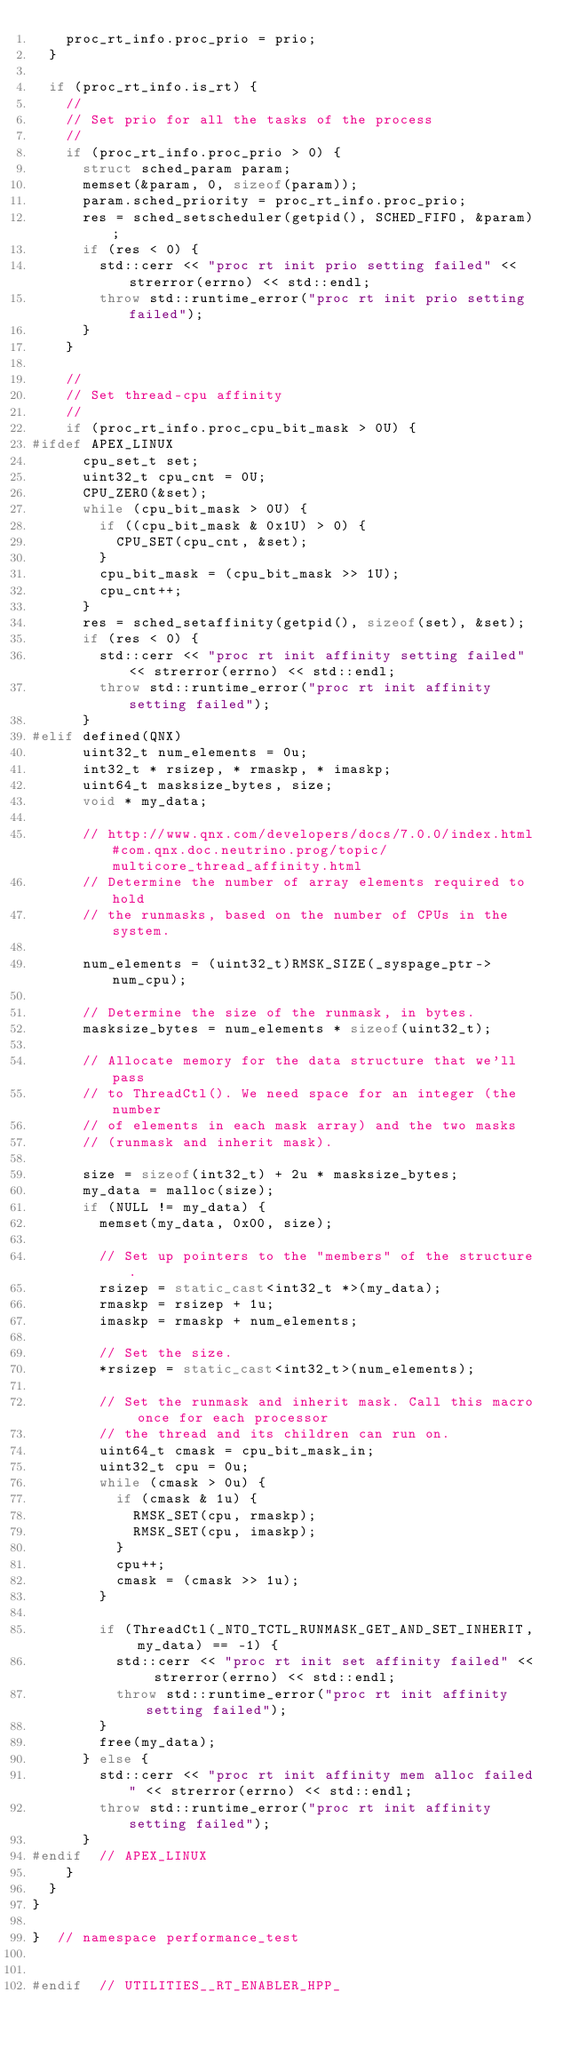Convert code to text. <code><loc_0><loc_0><loc_500><loc_500><_C++_>    proc_rt_info.proc_prio = prio;
  }

  if (proc_rt_info.is_rt) {
    //
    // Set prio for all the tasks of the process
    //
    if (proc_rt_info.proc_prio > 0) {
      struct sched_param param;
      memset(&param, 0, sizeof(param));
      param.sched_priority = proc_rt_info.proc_prio;
      res = sched_setscheduler(getpid(), SCHED_FIFO, &param);
      if (res < 0) {
        std::cerr << "proc rt init prio setting failed" << strerror(errno) << std::endl;
        throw std::runtime_error("proc rt init prio setting failed");
      }
    }

    //
    // Set thread-cpu affinity
    //
    if (proc_rt_info.proc_cpu_bit_mask > 0U) {
#ifdef APEX_LINUX
      cpu_set_t set;
      uint32_t cpu_cnt = 0U;
      CPU_ZERO(&set);
      while (cpu_bit_mask > 0U) {
        if ((cpu_bit_mask & 0x1U) > 0) {
          CPU_SET(cpu_cnt, &set);
        }
        cpu_bit_mask = (cpu_bit_mask >> 1U);
        cpu_cnt++;
      }
      res = sched_setaffinity(getpid(), sizeof(set), &set);
      if (res < 0) {
        std::cerr << "proc rt init affinity setting failed" << strerror(errno) << std::endl;
        throw std::runtime_error("proc rt init affinity setting failed");
      }
#elif defined(QNX)
      uint32_t num_elements = 0u;
      int32_t * rsizep, * rmaskp, * imaskp;
      uint64_t masksize_bytes, size;
      void * my_data;

      // http://www.qnx.com/developers/docs/7.0.0/index.html#com.qnx.doc.neutrino.prog/topic/multicore_thread_affinity.html
      // Determine the number of array elements required to hold
      // the runmasks, based on the number of CPUs in the system.

      num_elements = (uint32_t)RMSK_SIZE(_syspage_ptr->num_cpu);

      // Determine the size of the runmask, in bytes.
      masksize_bytes = num_elements * sizeof(uint32_t);

      // Allocate memory for the data structure that we'll pass
      // to ThreadCtl(). We need space for an integer (the number
      // of elements in each mask array) and the two masks
      // (runmask and inherit mask).

      size = sizeof(int32_t) + 2u * masksize_bytes;
      my_data = malloc(size);
      if (NULL != my_data) {
        memset(my_data, 0x00, size);

        // Set up pointers to the "members" of the structure.
        rsizep = static_cast<int32_t *>(my_data);
        rmaskp = rsizep + 1u;
        imaskp = rmaskp + num_elements;

        // Set the size.
        *rsizep = static_cast<int32_t>(num_elements);

        // Set the runmask and inherit mask. Call this macro once for each processor
        // the thread and its children can run on.
        uint64_t cmask = cpu_bit_mask_in;
        uint32_t cpu = 0u;
        while (cmask > 0u) {
          if (cmask & 1u) {
            RMSK_SET(cpu, rmaskp);
            RMSK_SET(cpu, imaskp);
          }
          cpu++;
          cmask = (cmask >> 1u);
        }

        if (ThreadCtl(_NTO_TCTL_RUNMASK_GET_AND_SET_INHERIT, my_data) == -1) {
          std::cerr << "proc rt init set affinity failed" << strerror(errno) << std::endl;
          throw std::runtime_error("proc rt init affinity setting failed");
        }
        free(my_data);
      } else {
        std::cerr << "proc rt init affinity mem alloc failed" << strerror(errno) << std::endl;
        throw std::runtime_error("proc rt init affinity setting failed");
      }
#endif  // APEX_LINUX
    }
  }
}

}  // namespace performance_test


#endif  // UTILITIES__RT_ENABLER_HPP_
</code> 